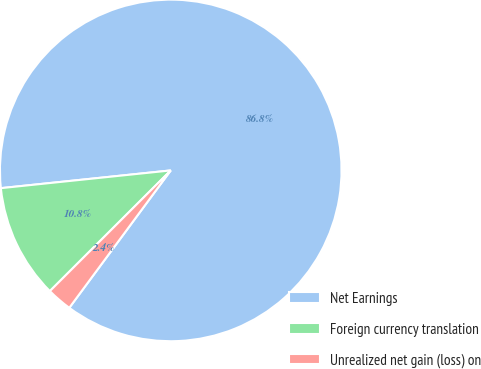Convert chart to OTSL. <chart><loc_0><loc_0><loc_500><loc_500><pie_chart><fcel>Net Earnings<fcel>Foreign currency translation<fcel>Unrealized net gain (loss) on<nl><fcel>86.77%<fcel>10.83%<fcel>2.39%<nl></chart> 